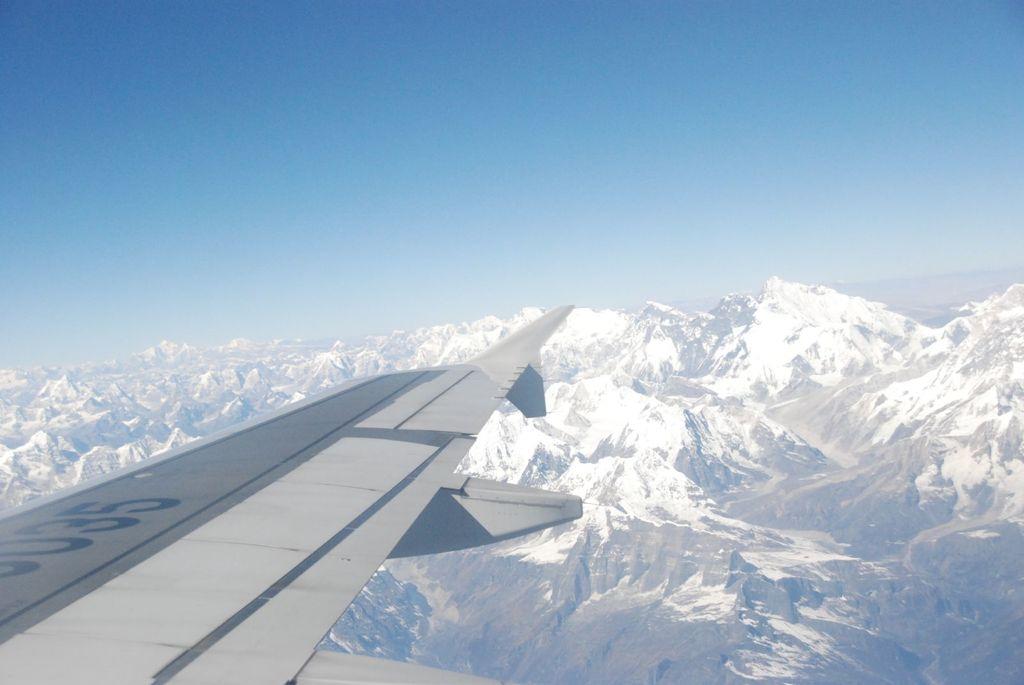What's the last number on the wing?
Keep it short and to the point. 5. 